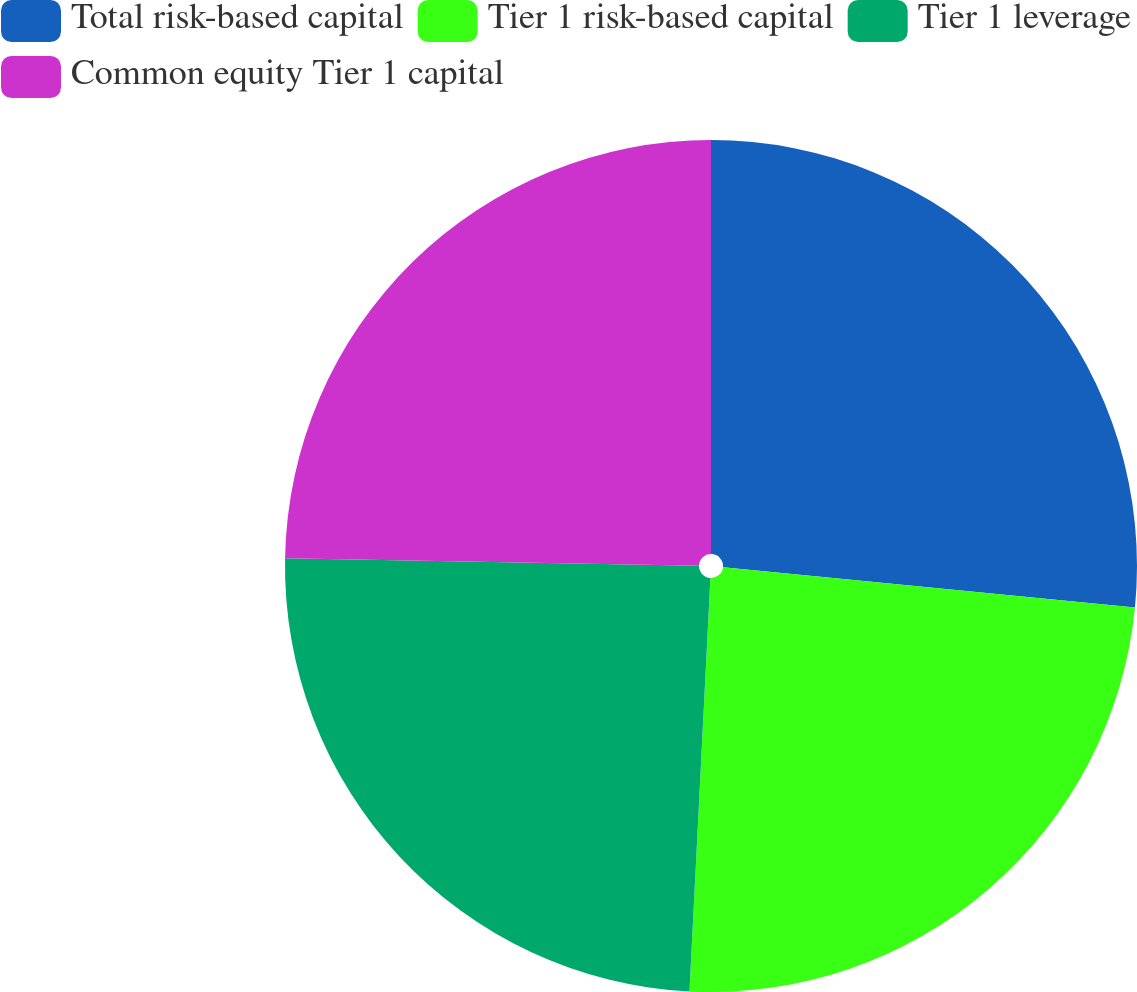Convert chart to OTSL. <chart><loc_0><loc_0><loc_500><loc_500><pie_chart><fcel>Total risk-based capital<fcel>Tier 1 risk-based capital<fcel>Tier 1 leverage<fcel>Common equity Tier 1 capital<nl><fcel>26.55%<fcel>24.25%<fcel>24.48%<fcel>24.71%<nl></chart> 